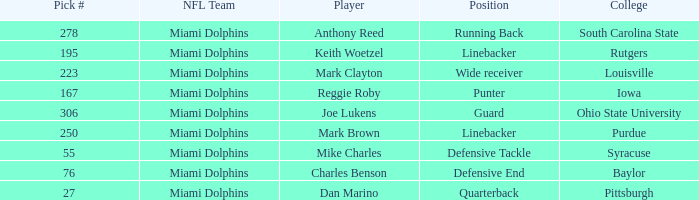Which Player has a Pick # lower than 223 and a Defensive End Position? Charles Benson. 